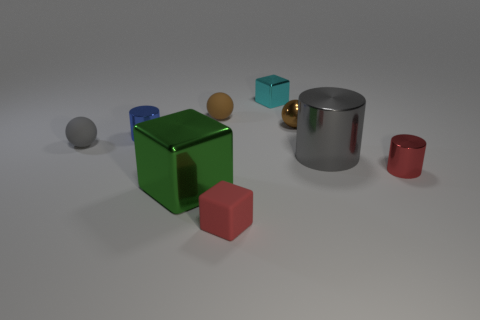Subtract all large green cubes. How many cubes are left? 2 Subtract 2 cylinders. How many cylinders are left? 1 Subtract all red cubes. How many cubes are left? 2 Subtract all cylinders. How many objects are left? 6 Subtract 0 cyan spheres. How many objects are left? 9 Subtract all gray spheres. Subtract all purple cylinders. How many spheres are left? 2 Subtract all cyan spheres. How many brown cylinders are left? 0 Subtract all green objects. Subtract all large green shiny balls. How many objects are left? 8 Add 6 red cubes. How many red cubes are left? 7 Add 8 small purple metallic balls. How many small purple metallic balls exist? 8 